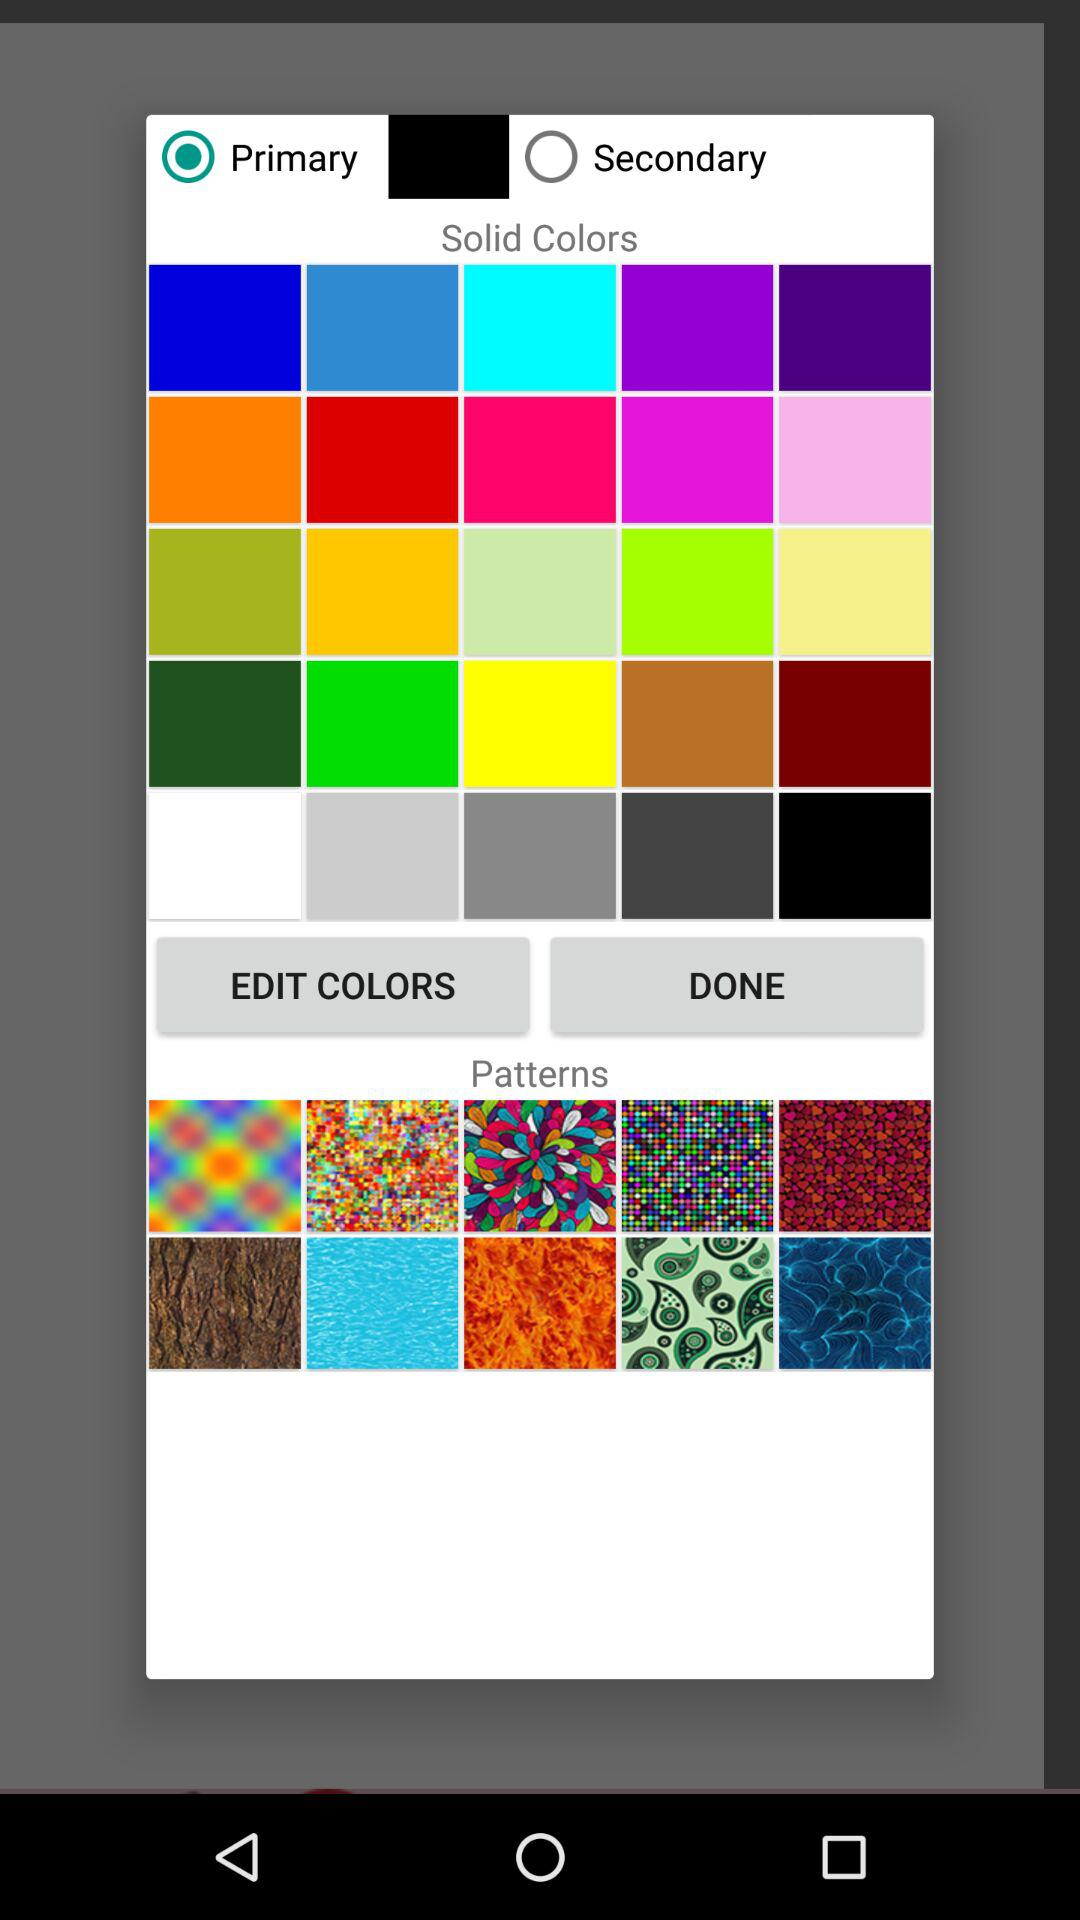What is the status of the "Primary"? The status is "on". 